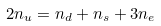Convert formula to latex. <formula><loc_0><loc_0><loc_500><loc_500>2 n _ { u } = n _ { d } + n _ { s } + 3 n _ { e }</formula> 